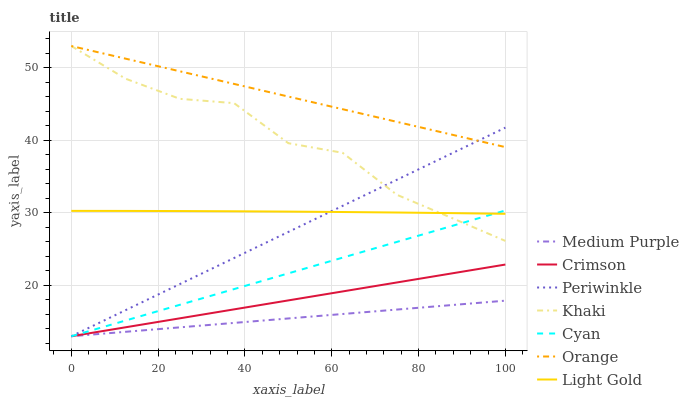Does Medium Purple have the minimum area under the curve?
Answer yes or no. Yes. Does Orange have the maximum area under the curve?
Answer yes or no. Yes. Does Orange have the minimum area under the curve?
Answer yes or no. No. Does Medium Purple have the maximum area under the curve?
Answer yes or no. No. Is Medium Purple the smoothest?
Answer yes or no. Yes. Is Khaki the roughest?
Answer yes or no. Yes. Is Orange the smoothest?
Answer yes or no. No. Is Orange the roughest?
Answer yes or no. No. Does Medium Purple have the lowest value?
Answer yes or no. Yes. Does Orange have the lowest value?
Answer yes or no. No. Does Orange have the highest value?
Answer yes or no. Yes. Does Medium Purple have the highest value?
Answer yes or no. No. Is Medium Purple less than Light Gold?
Answer yes or no. Yes. Is Light Gold greater than Crimson?
Answer yes or no. Yes. Does Cyan intersect Periwinkle?
Answer yes or no. Yes. Is Cyan less than Periwinkle?
Answer yes or no. No. Is Cyan greater than Periwinkle?
Answer yes or no. No. Does Medium Purple intersect Light Gold?
Answer yes or no. No. 